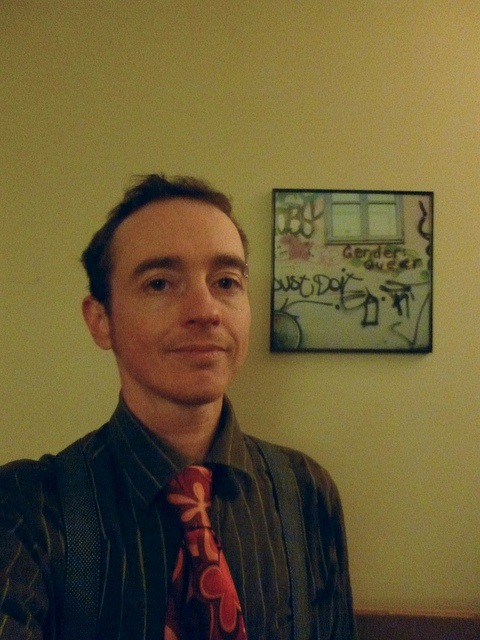Describe the objects in this image and their specific colors. I can see people in olive, black, maroon, and brown tones and tie in olive, black, maroon, and brown tones in this image. 